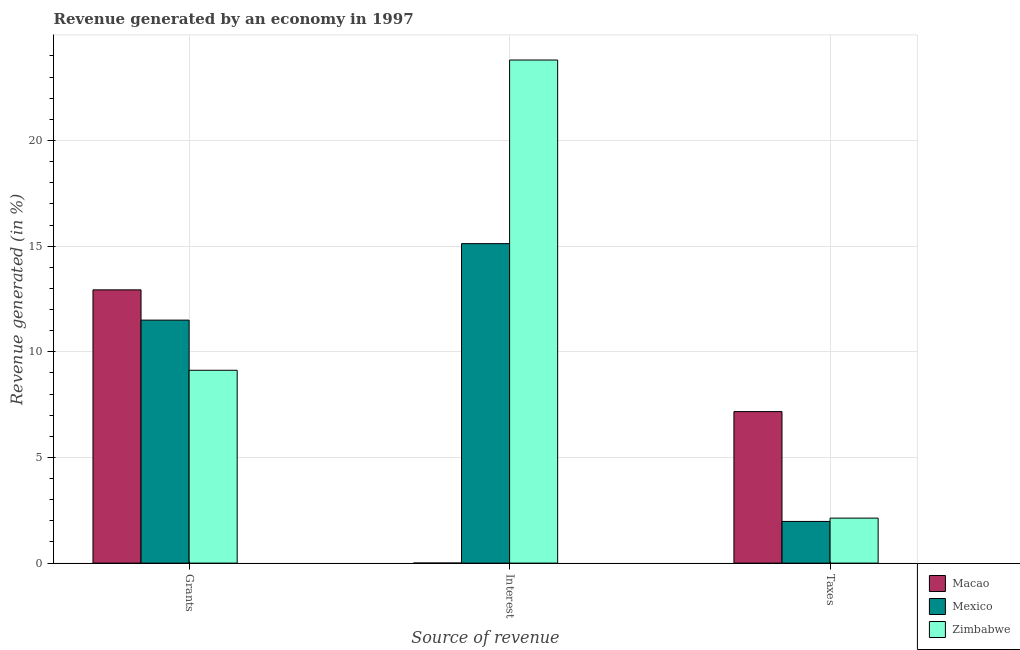How many different coloured bars are there?
Your answer should be compact. 3. How many groups of bars are there?
Make the answer very short. 3. Are the number of bars on each tick of the X-axis equal?
Your answer should be compact. Yes. How many bars are there on the 1st tick from the left?
Offer a very short reply. 3. How many bars are there on the 1st tick from the right?
Make the answer very short. 3. What is the label of the 1st group of bars from the left?
Keep it short and to the point. Grants. What is the percentage of revenue generated by grants in Zimbabwe?
Provide a short and direct response. 9.13. Across all countries, what is the maximum percentage of revenue generated by grants?
Offer a terse response. 12.93. Across all countries, what is the minimum percentage of revenue generated by taxes?
Your answer should be compact. 1.97. In which country was the percentage of revenue generated by grants maximum?
Your response must be concise. Macao. What is the total percentage of revenue generated by interest in the graph?
Offer a very short reply. 38.93. What is the difference between the percentage of revenue generated by taxes in Macao and that in Zimbabwe?
Provide a succinct answer. 5.04. What is the difference between the percentage of revenue generated by interest in Zimbabwe and the percentage of revenue generated by grants in Macao?
Offer a terse response. 10.88. What is the average percentage of revenue generated by taxes per country?
Ensure brevity in your answer.  3.76. What is the difference between the percentage of revenue generated by grants and percentage of revenue generated by interest in Macao?
Make the answer very short. 12.93. In how many countries, is the percentage of revenue generated by interest greater than 8 %?
Keep it short and to the point. 2. What is the ratio of the percentage of revenue generated by interest in Zimbabwe to that in Macao?
Your answer should be compact. 1.34e+04. Is the difference between the percentage of revenue generated by taxes in Mexico and Zimbabwe greater than the difference between the percentage of revenue generated by grants in Mexico and Zimbabwe?
Ensure brevity in your answer.  No. What is the difference between the highest and the second highest percentage of revenue generated by interest?
Your answer should be compact. 8.69. What is the difference between the highest and the lowest percentage of revenue generated by interest?
Provide a short and direct response. 23.81. Is the sum of the percentage of revenue generated by grants in Mexico and Macao greater than the maximum percentage of revenue generated by interest across all countries?
Give a very brief answer. Yes. What does the 2nd bar from the left in Taxes represents?
Provide a short and direct response. Mexico. What does the 2nd bar from the right in Interest represents?
Ensure brevity in your answer.  Mexico. How many bars are there?
Provide a short and direct response. 9. How many countries are there in the graph?
Make the answer very short. 3. What is the difference between two consecutive major ticks on the Y-axis?
Provide a succinct answer. 5. Does the graph contain any zero values?
Keep it short and to the point. No. Does the graph contain grids?
Offer a terse response. Yes. Where does the legend appear in the graph?
Your answer should be very brief. Bottom right. How many legend labels are there?
Ensure brevity in your answer.  3. How are the legend labels stacked?
Make the answer very short. Vertical. What is the title of the graph?
Offer a terse response. Revenue generated by an economy in 1997. Does "Benin" appear as one of the legend labels in the graph?
Give a very brief answer. No. What is the label or title of the X-axis?
Provide a short and direct response. Source of revenue. What is the label or title of the Y-axis?
Provide a short and direct response. Revenue generated (in %). What is the Revenue generated (in %) of Macao in Grants?
Your response must be concise. 12.93. What is the Revenue generated (in %) in Mexico in Grants?
Your answer should be very brief. 11.5. What is the Revenue generated (in %) of Zimbabwe in Grants?
Ensure brevity in your answer.  9.13. What is the Revenue generated (in %) in Macao in Interest?
Keep it short and to the point. 0. What is the Revenue generated (in %) in Mexico in Interest?
Keep it short and to the point. 15.12. What is the Revenue generated (in %) of Zimbabwe in Interest?
Provide a succinct answer. 23.81. What is the Revenue generated (in %) in Macao in Taxes?
Your answer should be compact. 7.17. What is the Revenue generated (in %) in Mexico in Taxes?
Your response must be concise. 1.97. What is the Revenue generated (in %) in Zimbabwe in Taxes?
Give a very brief answer. 2.13. Across all Source of revenue, what is the maximum Revenue generated (in %) in Macao?
Your answer should be compact. 12.93. Across all Source of revenue, what is the maximum Revenue generated (in %) of Mexico?
Give a very brief answer. 15.12. Across all Source of revenue, what is the maximum Revenue generated (in %) of Zimbabwe?
Offer a terse response. 23.81. Across all Source of revenue, what is the minimum Revenue generated (in %) of Macao?
Provide a succinct answer. 0. Across all Source of revenue, what is the minimum Revenue generated (in %) of Mexico?
Provide a short and direct response. 1.97. Across all Source of revenue, what is the minimum Revenue generated (in %) in Zimbabwe?
Provide a short and direct response. 2.13. What is the total Revenue generated (in %) of Macao in the graph?
Offer a terse response. 20.1. What is the total Revenue generated (in %) of Mexico in the graph?
Offer a terse response. 28.59. What is the total Revenue generated (in %) of Zimbabwe in the graph?
Provide a short and direct response. 35.06. What is the difference between the Revenue generated (in %) of Macao in Grants and that in Interest?
Your response must be concise. 12.93. What is the difference between the Revenue generated (in %) of Mexico in Grants and that in Interest?
Provide a short and direct response. -3.62. What is the difference between the Revenue generated (in %) in Zimbabwe in Grants and that in Interest?
Give a very brief answer. -14.68. What is the difference between the Revenue generated (in %) of Macao in Grants and that in Taxes?
Offer a terse response. 5.76. What is the difference between the Revenue generated (in %) of Mexico in Grants and that in Taxes?
Give a very brief answer. 9.53. What is the difference between the Revenue generated (in %) of Zimbabwe in Grants and that in Taxes?
Your response must be concise. 7. What is the difference between the Revenue generated (in %) of Macao in Interest and that in Taxes?
Your answer should be compact. -7.17. What is the difference between the Revenue generated (in %) in Mexico in Interest and that in Taxes?
Ensure brevity in your answer.  13.15. What is the difference between the Revenue generated (in %) in Zimbabwe in Interest and that in Taxes?
Ensure brevity in your answer.  21.68. What is the difference between the Revenue generated (in %) in Macao in Grants and the Revenue generated (in %) in Mexico in Interest?
Your answer should be compact. -2.19. What is the difference between the Revenue generated (in %) of Macao in Grants and the Revenue generated (in %) of Zimbabwe in Interest?
Provide a short and direct response. -10.88. What is the difference between the Revenue generated (in %) of Mexico in Grants and the Revenue generated (in %) of Zimbabwe in Interest?
Your response must be concise. -12.31. What is the difference between the Revenue generated (in %) in Macao in Grants and the Revenue generated (in %) in Mexico in Taxes?
Provide a succinct answer. 10.96. What is the difference between the Revenue generated (in %) in Macao in Grants and the Revenue generated (in %) in Zimbabwe in Taxes?
Your answer should be very brief. 10.8. What is the difference between the Revenue generated (in %) in Mexico in Grants and the Revenue generated (in %) in Zimbabwe in Taxes?
Your response must be concise. 9.37. What is the difference between the Revenue generated (in %) in Macao in Interest and the Revenue generated (in %) in Mexico in Taxes?
Offer a terse response. -1.97. What is the difference between the Revenue generated (in %) of Macao in Interest and the Revenue generated (in %) of Zimbabwe in Taxes?
Give a very brief answer. -2.13. What is the difference between the Revenue generated (in %) of Mexico in Interest and the Revenue generated (in %) of Zimbabwe in Taxes?
Your response must be concise. 12.99. What is the average Revenue generated (in %) of Macao per Source of revenue?
Your answer should be compact. 6.7. What is the average Revenue generated (in %) of Mexico per Source of revenue?
Your response must be concise. 9.53. What is the average Revenue generated (in %) in Zimbabwe per Source of revenue?
Ensure brevity in your answer.  11.69. What is the difference between the Revenue generated (in %) in Macao and Revenue generated (in %) in Mexico in Grants?
Provide a succinct answer. 1.43. What is the difference between the Revenue generated (in %) of Macao and Revenue generated (in %) of Zimbabwe in Grants?
Provide a succinct answer. 3.81. What is the difference between the Revenue generated (in %) in Mexico and Revenue generated (in %) in Zimbabwe in Grants?
Your answer should be compact. 2.37. What is the difference between the Revenue generated (in %) in Macao and Revenue generated (in %) in Mexico in Interest?
Provide a succinct answer. -15.12. What is the difference between the Revenue generated (in %) of Macao and Revenue generated (in %) of Zimbabwe in Interest?
Offer a very short reply. -23.81. What is the difference between the Revenue generated (in %) in Mexico and Revenue generated (in %) in Zimbabwe in Interest?
Offer a terse response. -8.69. What is the difference between the Revenue generated (in %) in Macao and Revenue generated (in %) in Mexico in Taxes?
Ensure brevity in your answer.  5.2. What is the difference between the Revenue generated (in %) in Macao and Revenue generated (in %) in Zimbabwe in Taxes?
Ensure brevity in your answer.  5.04. What is the difference between the Revenue generated (in %) of Mexico and Revenue generated (in %) of Zimbabwe in Taxes?
Your response must be concise. -0.16. What is the ratio of the Revenue generated (in %) in Macao in Grants to that in Interest?
Offer a terse response. 7256.79. What is the ratio of the Revenue generated (in %) in Mexico in Grants to that in Interest?
Ensure brevity in your answer.  0.76. What is the ratio of the Revenue generated (in %) of Zimbabwe in Grants to that in Interest?
Offer a terse response. 0.38. What is the ratio of the Revenue generated (in %) in Macao in Grants to that in Taxes?
Offer a very short reply. 1.8. What is the ratio of the Revenue generated (in %) in Mexico in Grants to that in Taxes?
Make the answer very short. 5.83. What is the ratio of the Revenue generated (in %) in Zimbabwe in Grants to that in Taxes?
Provide a succinct answer. 4.29. What is the ratio of the Revenue generated (in %) of Mexico in Interest to that in Taxes?
Your answer should be compact. 7.66. What is the ratio of the Revenue generated (in %) in Zimbabwe in Interest to that in Taxes?
Provide a short and direct response. 11.18. What is the difference between the highest and the second highest Revenue generated (in %) of Macao?
Make the answer very short. 5.76. What is the difference between the highest and the second highest Revenue generated (in %) of Mexico?
Your response must be concise. 3.62. What is the difference between the highest and the second highest Revenue generated (in %) in Zimbabwe?
Give a very brief answer. 14.68. What is the difference between the highest and the lowest Revenue generated (in %) of Macao?
Give a very brief answer. 12.93. What is the difference between the highest and the lowest Revenue generated (in %) in Mexico?
Provide a succinct answer. 13.15. What is the difference between the highest and the lowest Revenue generated (in %) in Zimbabwe?
Your answer should be very brief. 21.68. 